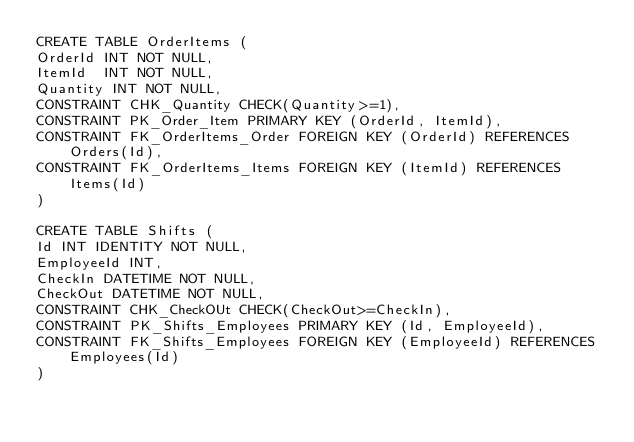<code> <loc_0><loc_0><loc_500><loc_500><_SQL_>CREATE TABLE OrderItems (
OrderId INT NOT NULL,
ItemId  INT NOT NULL,
Quantity INT NOT NULL,
CONSTRAINT CHK_Quantity CHECK(Quantity>=1),
CONSTRAINT PK_Order_Item PRIMARY KEY (OrderId, ItemId),
CONSTRAINT FK_OrderItems_Order FOREIGN KEY (OrderId) REFERENCES Orders(Id),
CONSTRAINT FK_OrderItems_Items FOREIGN KEY (ItemId) REFERENCES Items(Id)
)

CREATE TABLE Shifts (
Id INT IDENTITY NOT NULL,
EmployeeId INT,
CheckIn DATETIME NOT NULL,
CheckOut DATETIME NOT NULL,
CONSTRAINT CHK_CheckOUt CHECK(CheckOut>=CheckIn), 
CONSTRAINT PK_Shifts_Employees PRIMARY KEY (Id, EmployeeId),
CONSTRAINT FK_Shifts_Employees FOREIGN KEY (EmployeeId) REFERENCES Employees(Id)
)
</code> 